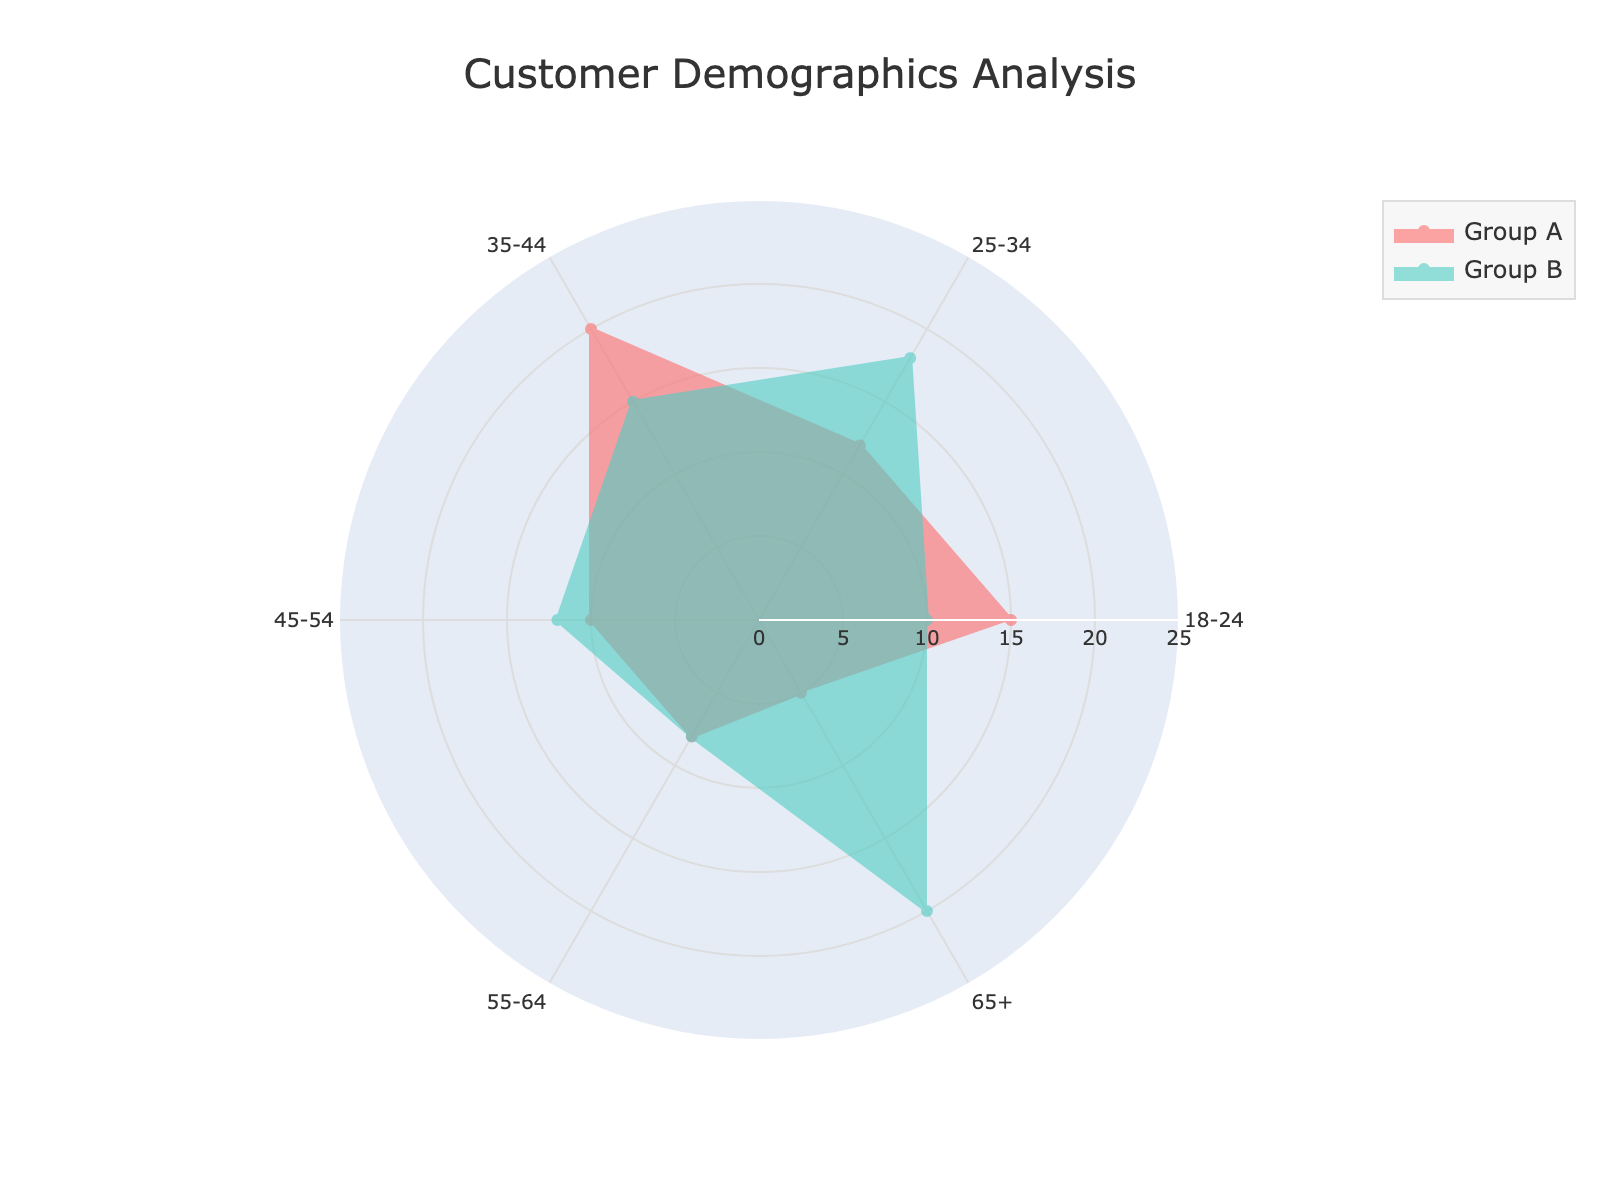how many age categories are shown in the radar chart? the radar chart shows different percentage values for various age categories, ranging from 18-24 to 65+. There are 6 unique age categories.
Answer: 6 which customer group has the highest percentage in the 35-44 age category? By observing the radar chart, the value for group A in 35-44 is 20%, while for group B it is 15%. Thus, group A has the highest percentage.
Answer: Group A what's the total percentage for the 45-54 age category combining both groups? summing up the percentage values for both group A and group B in the 45-54 age category (10% for group A and 12% for group B) results in a total of 22%.
Answer: 22% which age category shows the most significant difference in percentages between the two groups? the radar chart shows the largest percentage difference between the 65+ age category, where group A has 5%, and group B has 20%. This results in a 15 percentage point difference.
Answer: 65+ are there any age categories where both customer groups have the same percentage? looking through the radar chart for matching values, both groups have the same percentage values in the 55-64 age category, showing 8%.
Answer: 55-64 how does the percentage of group B in the 18-24 age category compare to that of group A? in the 18-24 age category, group B has a percentage of 10%, while group A has 15%. Group B is lower by 5%.
Answer: Group B is lower how do the group percentages in the 25-34 and 45-54 age categories compare overall? group A's percentages in 25-34 and 45-54 are 12% and 10%, respectively, which combine to 22%. Similarly, group B's percentages in 25-34 and 45-54 are 18% and 12%, respectively, amounting to 30%.
Answer: group B is higher what is the average percentage value for group A across all age categories? summing up the percentage values for group A (15, 12, 20, 10, 8, 5) gives a total of 70. Dividing by the 6 age categories (70/6) results in an average value of approximately 11.67%.
Answer: 11.67% which age category shows the lowest percentage for either group? the radar chart reveals that the age category 65+ for group A has the lowest percentage value of 5%.
Answer: 65+ for group A 